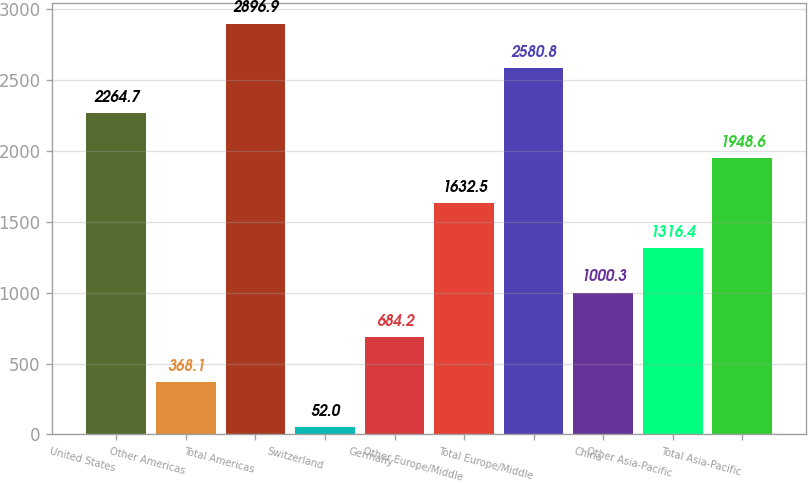Convert chart. <chart><loc_0><loc_0><loc_500><loc_500><bar_chart><fcel>United States<fcel>Other Americas<fcel>Total Americas<fcel>Switzerland<fcel>Germany<fcel>Other Europe/Middle<fcel>Total Europe/Middle<fcel>China<fcel>Other Asia-Pacific<fcel>Total Asia-Pacific<nl><fcel>2264.7<fcel>368.1<fcel>2896.9<fcel>52<fcel>684.2<fcel>1632.5<fcel>2580.8<fcel>1000.3<fcel>1316.4<fcel>1948.6<nl></chart> 